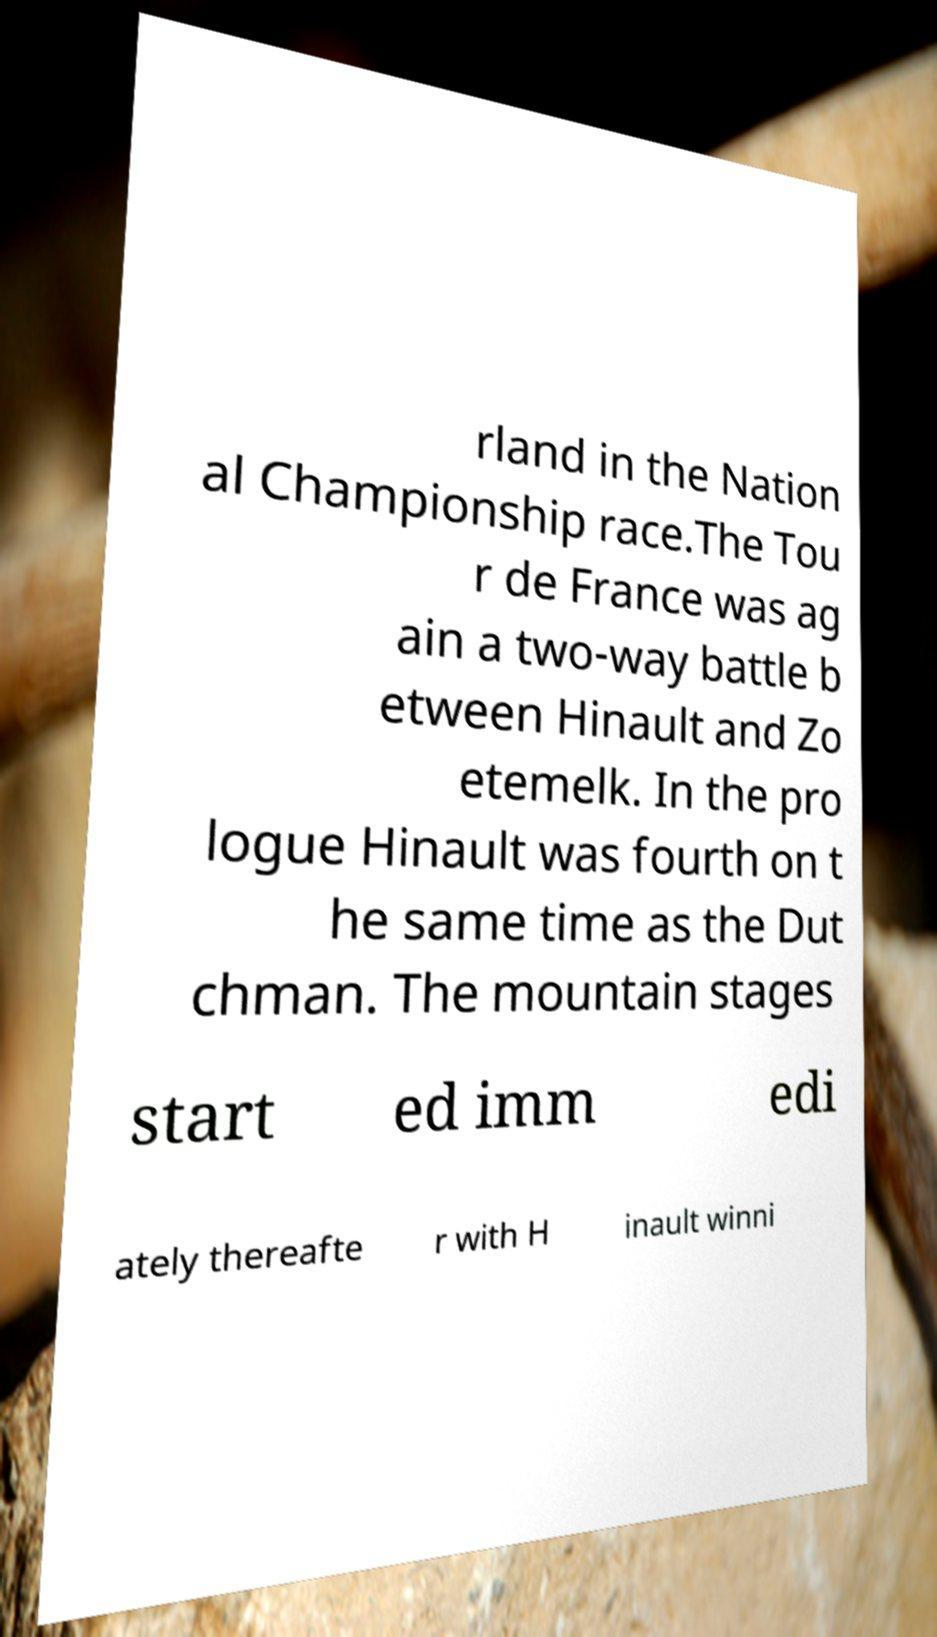Can you accurately transcribe the text from the provided image for me? rland in the Nation al Championship race.The Tou r de France was ag ain a two-way battle b etween Hinault and Zo etemelk. In the pro logue Hinault was fourth on t he same time as the Dut chman. The mountain stages start ed imm edi ately thereafte r with H inault winni 